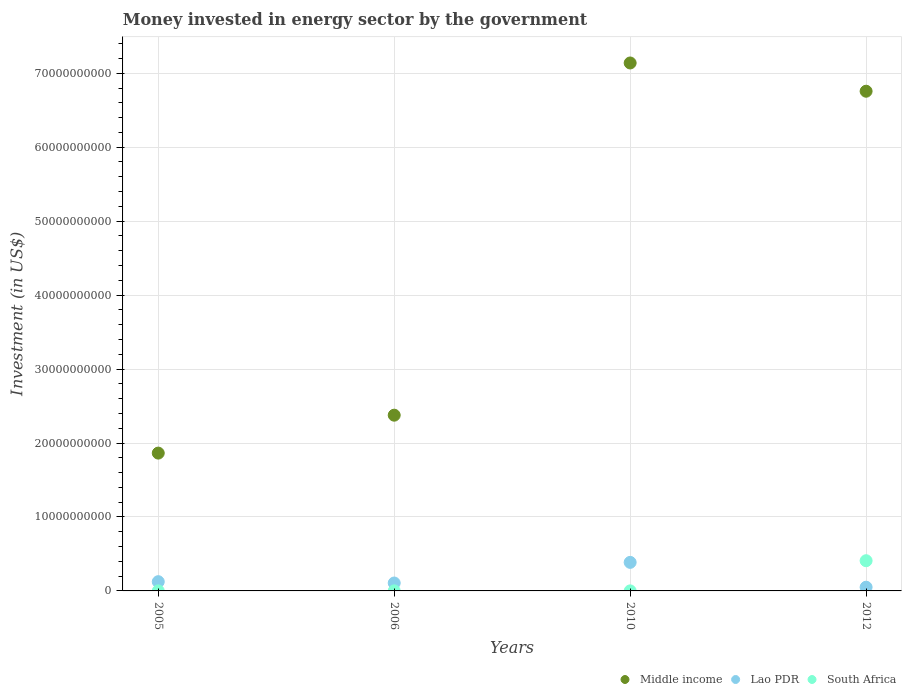Is the number of dotlines equal to the number of legend labels?
Your response must be concise. Yes. What is the money spent in energy sector in South Africa in 2006?
Your response must be concise. 9.90e+06. Across all years, what is the maximum money spent in energy sector in South Africa?
Your answer should be compact. 4.08e+09. Across all years, what is the minimum money spent in energy sector in Lao PDR?
Ensure brevity in your answer.  5.01e+08. In which year was the money spent in energy sector in South Africa maximum?
Your answer should be very brief. 2012. In which year was the money spent in energy sector in Lao PDR minimum?
Give a very brief answer. 2012. What is the total money spent in energy sector in Lao PDR in the graph?
Give a very brief answer. 6.68e+09. What is the difference between the money spent in energy sector in Lao PDR in 2010 and that in 2012?
Your answer should be compact. 3.36e+09. What is the difference between the money spent in energy sector in Middle income in 2005 and the money spent in energy sector in South Africa in 2012?
Keep it short and to the point. 1.46e+1. What is the average money spent in energy sector in South Africa per year?
Provide a succinct answer. 1.03e+09. In the year 2010, what is the difference between the money spent in energy sector in Lao PDR and money spent in energy sector in South Africa?
Make the answer very short. 3.85e+09. What is the ratio of the money spent in energy sector in Lao PDR in 2005 to that in 2006?
Your answer should be compact. 1.17. Is the money spent in energy sector in South Africa in 2006 less than that in 2012?
Provide a short and direct response. Yes. What is the difference between the highest and the second highest money spent in energy sector in Lao PDR?
Ensure brevity in your answer.  2.61e+09. What is the difference between the highest and the lowest money spent in energy sector in Lao PDR?
Your answer should be compact. 3.36e+09. In how many years, is the money spent in energy sector in South Africa greater than the average money spent in energy sector in South Africa taken over all years?
Offer a very short reply. 1. Is the money spent in energy sector in Lao PDR strictly greater than the money spent in energy sector in Middle income over the years?
Your answer should be compact. No. How many dotlines are there?
Offer a terse response. 3. How many years are there in the graph?
Make the answer very short. 4. Does the graph contain grids?
Your answer should be very brief. Yes. Where does the legend appear in the graph?
Give a very brief answer. Bottom right. How many legend labels are there?
Give a very brief answer. 3. How are the legend labels stacked?
Offer a very short reply. Horizontal. What is the title of the graph?
Your response must be concise. Money invested in energy sector by the government. What is the label or title of the X-axis?
Offer a terse response. Years. What is the label or title of the Y-axis?
Offer a terse response. Investment (in US$). What is the Investment (in US$) in Middle income in 2005?
Offer a very short reply. 1.86e+1. What is the Investment (in US$) in Lao PDR in 2005?
Provide a succinct answer. 1.25e+09. What is the Investment (in US$) in Middle income in 2006?
Make the answer very short. 2.38e+1. What is the Investment (in US$) in Lao PDR in 2006?
Give a very brief answer. 1.07e+09. What is the Investment (in US$) in South Africa in 2006?
Your answer should be very brief. 9.90e+06. What is the Investment (in US$) in Middle income in 2010?
Give a very brief answer. 7.14e+1. What is the Investment (in US$) of Lao PDR in 2010?
Your response must be concise. 3.86e+09. What is the Investment (in US$) of Middle income in 2012?
Provide a succinct answer. 6.76e+1. What is the Investment (in US$) of Lao PDR in 2012?
Make the answer very short. 5.01e+08. What is the Investment (in US$) of South Africa in 2012?
Keep it short and to the point. 4.08e+09. Across all years, what is the maximum Investment (in US$) of Middle income?
Keep it short and to the point. 7.14e+1. Across all years, what is the maximum Investment (in US$) in Lao PDR?
Ensure brevity in your answer.  3.86e+09. Across all years, what is the maximum Investment (in US$) of South Africa?
Give a very brief answer. 4.08e+09. Across all years, what is the minimum Investment (in US$) in Middle income?
Make the answer very short. 1.86e+1. Across all years, what is the minimum Investment (in US$) in Lao PDR?
Keep it short and to the point. 5.01e+08. What is the total Investment (in US$) of Middle income in the graph?
Your answer should be very brief. 1.81e+11. What is the total Investment (in US$) of Lao PDR in the graph?
Offer a very short reply. 6.68e+09. What is the total Investment (in US$) in South Africa in the graph?
Ensure brevity in your answer.  4.11e+09. What is the difference between the Investment (in US$) of Middle income in 2005 and that in 2006?
Provide a short and direct response. -5.13e+09. What is the difference between the Investment (in US$) in Lao PDR in 2005 and that in 2006?
Your response must be concise. 1.80e+08. What is the difference between the Investment (in US$) of South Africa in 2005 and that in 2006?
Your response must be concise. -2.90e+06. What is the difference between the Investment (in US$) in Middle income in 2005 and that in 2010?
Give a very brief answer. -5.27e+1. What is the difference between the Investment (in US$) in Lao PDR in 2005 and that in 2010?
Provide a short and direct response. -2.61e+09. What is the difference between the Investment (in US$) of Middle income in 2005 and that in 2012?
Your response must be concise. -4.89e+1. What is the difference between the Investment (in US$) of Lao PDR in 2005 and that in 2012?
Provide a short and direct response. 7.49e+08. What is the difference between the Investment (in US$) in South Africa in 2005 and that in 2012?
Offer a very short reply. -4.08e+09. What is the difference between the Investment (in US$) in Middle income in 2006 and that in 2010?
Ensure brevity in your answer.  -4.76e+1. What is the difference between the Investment (in US$) of Lao PDR in 2006 and that in 2010?
Your answer should be compact. -2.79e+09. What is the difference between the Investment (in US$) of South Africa in 2006 and that in 2010?
Your answer should be compact. 3.90e+06. What is the difference between the Investment (in US$) in Middle income in 2006 and that in 2012?
Provide a short and direct response. -4.38e+1. What is the difference between the Investment (in US$) in Lao PDR in 2006 and that in 2012?
Offer a terse response. 5.69e+08. What is the difference between the Investment (in US$) of South Africa in 2006 and that in 2012?
Ensure brevity in your answer.  -4.07e+09. What is the difference between the Investment (in US$) in Middle income in 2010 and that in 2012?
Your response must be concise. 3.82e+09. What is the difference between the Investment (in US$) of Lao PDR in 2010 and that in 2012?
Give a very brief answer. 3.36e+09. What is the difference between the Investment (in US$) in South Africa in 2010 and that in 2012?
Provide a short and direct response. -4.08e+09. What is the difference between the Investment (in US$) of Middle income in 2005 and the Investment (in US$) of Lao PDR in 2006?
Keep it short and to the point. 1.76e+1. What is the difference between the Investment (in US$) in Middle income in 2005 and the Investment (in US$) in South Africa in 2006?
Your answer should be very brief. 1.86e+1. What is the difference between the Investment (in US$) of Lao PDR in 2005 and the Investment (in US$) of South Africa in 2006?
Keep it short and to the point. 1.24e+09. What is the difference between the Investment (in US$) in Middle income in 2005 and the Investment (in US$) in Lao PDR in 2010?
Provide a succinct answer. 1.48e+1. What is the difference between the Investment (in US$) of Middle income in 2005 and the Investment (in US$) of South Africa in 2010?
Ensure brevity in your answer.  1.86e+1. What is the difference between the Investment (in US$) in Lao PDR in 2005 and the Investment (in US$) in South Africa in 2010?
Your answer should be very brief. 1.24e+09. What is the difference between the Investment (in US$) of Middle income in 2005 and the Investment (in US$) of Lao PDR in 2012?
Make the answer very short. 1.81e+1. What is the difference between the Investment (in US$) of Middle income in 2005 and the Investment (in US$) of South Africa in 2012?
Give a very brief answer. 1.46e+1. What is the difference between the Investment (in US$) in Lao PDR in 2005 and the Investment (in US$) in South Africa in 2012?
Your response must be concise. -2.83e+09. What is the difference between the Investment (in US$) in Middle income in 2006 and the Investment (in US$) in Lao PDR in 2010?
Keep it short and to the point. 1.99e+1. What is the difference between the Investment (in US$) in Middle income in 2006 and the Investment (in US$) in South Africa in 2010?
Ensure brevity in your answer.  2.38e+1. What is the difference between the Investment (in US$) of Lao PDR in 2006 and the Investment (in US$) of South Africa in 2010?
Offer a very short reply. 1.06e+09. What is the difference between the Investment (in US$) in Middle income in 2006 and the Investment (in US$) in Lao PDR in 2012?
Give a very brief answer. 2.33e+1. What is the difference between the Investment (in US$) in Middle income in 2006 and the Investment (in US$) in South Africa in 2012?
Keep it short and to the point. 1.97e+1. What is the difference between the Investment (in US$) of Lao PDR in 2006 and the Investment (in US$) of South Africa in 2012?
Keep it short and to the point. -3.01e+09. What is the difference between the Investment (in US$) of Middle income in 2010 and the Investment (in US$) of Lao PDR in 2012?
Give a very brief answer. 7.09e+1. What is the difference between the Investment (in US$) in Middle income in 2010 and the Investment (in US$) in South Africa in 2012?
Your answer should be very brief. 6.73e+1. What is the difference between the Investment (in US$) of Lao PDR in 2010 and the Investment (in US$) of South Africa in 2012?
Ensure brevity in your answer.  -2.24e+08. What is the average Investment (in US$) of Middle income per year?
Give a very brief answer. 4.53e+1. What is the average Investment (in US$) in Lao PDR per year?
Keep it short and to the point. 1.67e+09. What is the average Investment (in US$) in South Africa per year?
Keep it short and to the point. 1.03e+09. In the year 2005, what is the difference between the Investment (in US$) in Middle income and Investment (in US$) in Lao PDR?
Keep it short and to the point. 1.74e+1. In the year 2005, what is the difference between the Investment (in US$) in Middle income and Investment (in US$) in South Africa?
Your response must be concise. 1.86e+1. In the year 2005, what is the difference between the Investment (in US$) of Lao PDR and Investment (in US$) of South Africa?
Keep it short and to the point. 1.24e+09. In the year 2006, what is the difference between the Investment (in US$) of Middle income and Investment (in US$) of Lao PDR?
Ensure brevity in your answer.  2.27e+1. In the year 2006, what is the difference between the Investment (in US$) of Middle income and Investment (in US$) of South Africa?
Keep it short and to the point. 2.38e+1. In the year 2006, what is the difference between the Investment (in US$) of Lao PDR and Investment (in US$) of South Africa?
Your response must be concise. 1.06e+09. In the year 2010, what is the difference between the Investment (in US$) in Middle income and Investment (in US$) in Lao PDR?
Your answer should be compact. 6.75e+1. In the year 2010, what is the difference between the Investment (in US$) of Middle income and Investment (in US$) of South Africa?
Your answer should be very brief. 7.14e+1. In the year 2010, what is the difference between the Investment (in US$) in Lao PDR and Investment (in US$) in South Africa?
Ensure brevity in your answer.  3.85e+09. In the year 2012, what is the difference between the Investment (in US$) of Middle income and Investment (in US$) of Lao PDR?
Provide a succinct answer. 6.71e+1. In the year 2012, what is the difference between the Investment (in US$) in Middle income and Investment (in US$) in South Africa?
Make the answer very short. 6.35e+1. In the year 2012, what is the difference between the Investment (in US$) in Lao PDR and Investment (in US$) in South Africa?
Offer a terse response. -3.58e+09. What is the ratio of the Investment (in US$) of Middle income in 2005 to that in 2006?
Your response must be concise. 0.78. What is the ratio of the Investment (in US$) in Lao PDR in 2005 to that in 2006?
Give a very brief answer. 1.17. What is the ratio of the Investment (in US$) in South Africa in 2005 to that in 2006?
Make the answer very short. 0.71. What is the ratio of the Investment (in US$) of Middle income in 2005 to that in 2010?
Your response must be concise. 0.26. What is the ratio of the Investment (in US$) of Lao PDR in 2005 to that in 2010?
Make the answer very short. 0.32. What is the ratio of the Investment (in US$) of Middle income in 2005 to that in 2012?
Give a very brief answer. 0.28. What is the ratio of the Investment (in US$) in Lao PDR in 2005 to that in 2012?
Your answer should be very brief. 2.49. What is the ratio of the Investment (in US$) in South Africa in 2005 to that in 2012?
Make the answer very short. 0. What is the ratio of the Investment (in US$) in Middle income in 2006 to that in 2010?
Your answer should be compact. 0.33. What is the ratio of the Investment (in US$) in Lao PDR in 2006 to that in 2010?
Make the answer very short. 0.28. What is the ratio of the Investment (in US$) of South Africa in 2006 to that in 2010?
Your response must be concise. 1.65. What is the ratio of the Investment (in US$) of Middle income in 2006 to that in 2012?
Offer a terse response. 0.35. What is the ratio of the Investment (in US$) in Lao PDR in 2006 to that in 2012?
Provide a short and direct response. 2.13. What is the ratio of the Investment (in US$) of South Africa in 2006 to that in 2012?
Provide a short and direct response. 0. What is the ratio of the Investment (in US$) of Middle income in 2010 to that in 2012?
Your answer should be very brief. 1.06. What is the ratio of the Investment (in US$) in Lao PDR in 2010 to that in 2012?
Give a very brief answer. 7.7. What is the ratio of the Investment (in US$) of South Africa in 2010 to that in 2012?
Offer a terse response. 0. What is the difference between the highest and the second highest Investment (in US$) in Middle income?
Make the answer very short. 3.82e+09. What is the difference between the highest and the second highest Investment (in US$) in Lao PDR?
Offer a very short reply. 2.61e+09. What is the difference between the highest and the second highest Investment (in US$) of South Africa?
Ensure brevity in your answer.  4.07e+09. What is the difference between the highest and the lowest Investment (in US$) of Middle income?
Your answer should be very brief. 5.27e+1. What is the difference between the highest and the lowest Investment (in US$) in Lao PDR?
Offer a very short reply. 3.36e+09. What is the difference between the highest and the lowest Investment (in US$) of South Africa?
Make the answer very short. 4.08e+09. 